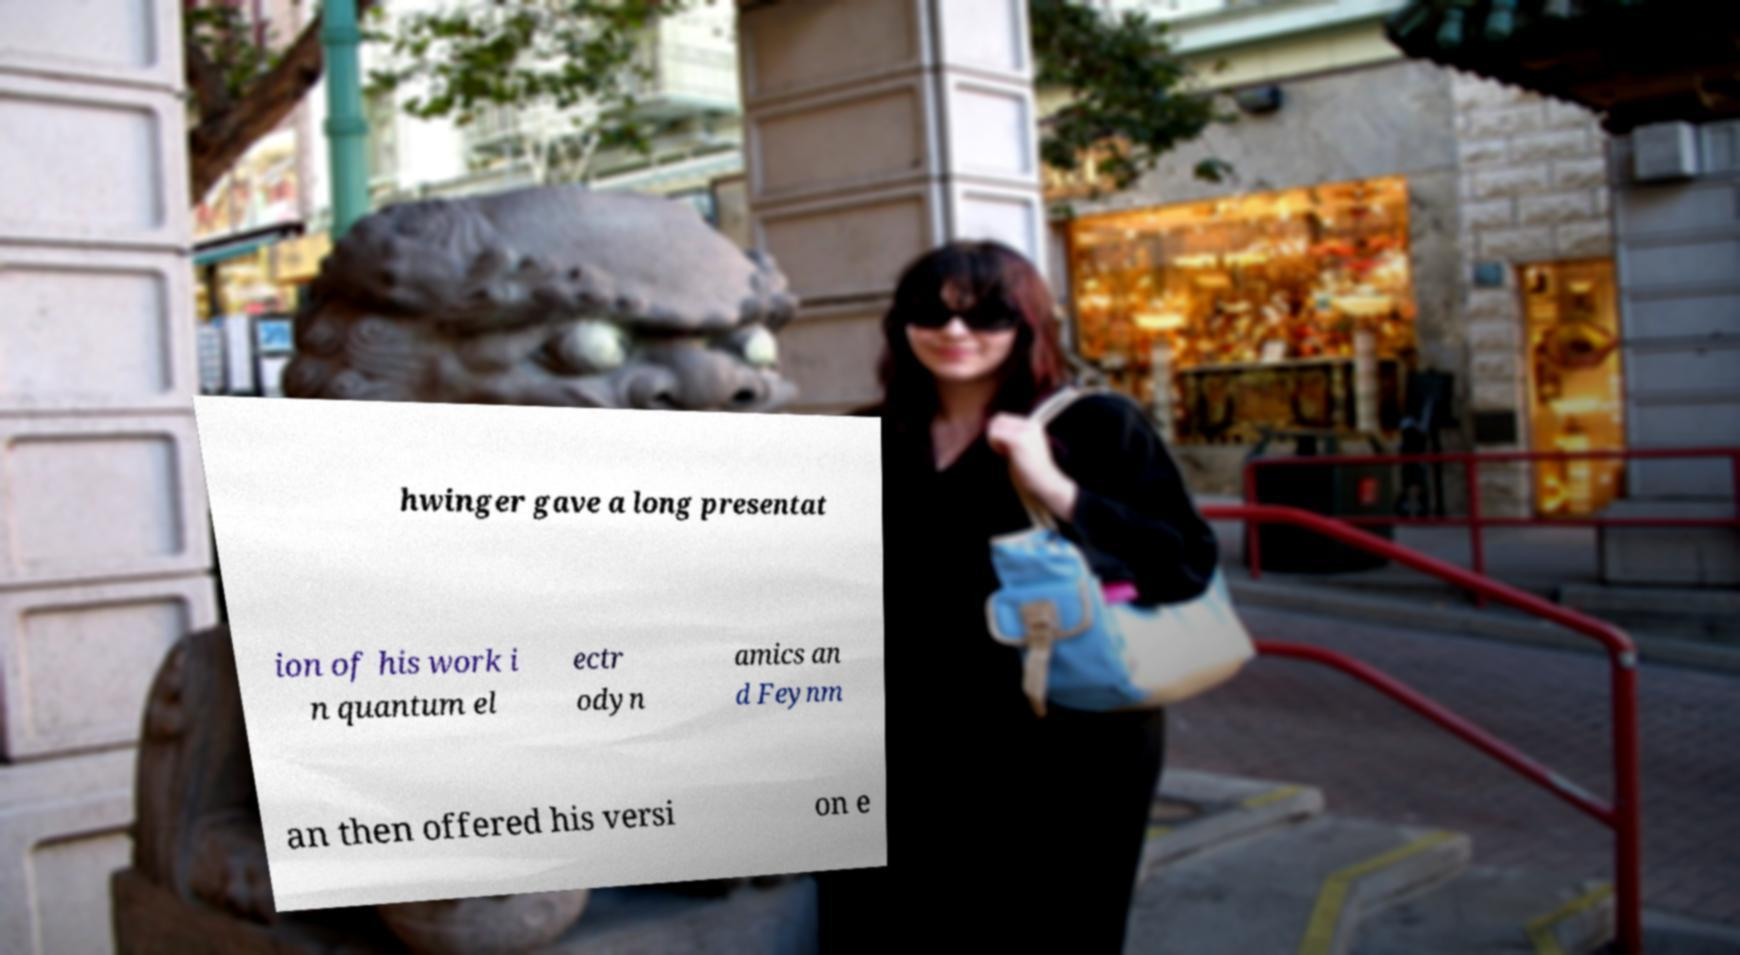There's text embedded in this image that I need extracted. Can you transcribe it verbatim? hwinger gave a long presentat ion of his work i n quantum el ectr odyn amics an d Feynm an then offered his versi on e 